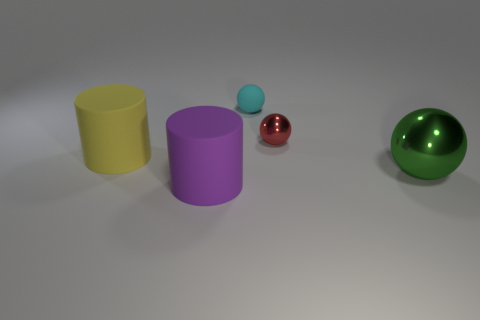There is a metal object that is behind the yellow object; does it have the same shape as the large object that is on the right side of the small matte sphere?
Offer a very short reply. Yes. The tiny shiny object is what color?
Offer a terse response. Red. How many metal things are either big cylinders or tiny red cylinders?
Your response must be concise. 0. There is another large rubber object that is the same shape as the purple rubber thing; what is its color?
Your answer should be compact. Yellow. Is there a big metallic block?
Make the answer very short. No. Do the big cylinder behind the purple matte cylinder and the cylinder right of the yellow rubber cylinder have the same material?
Provide a short and direct response. Yes. How many objects are either large rubber things that are right of the yellow thing or big things behind the big green thing?
Provide a succinct answer. 2. There is a thing behind the red metallic sphere; does it have the same color as the cylinder that is in front of the yellow matte thing?
Your answer should be very brief. No. What is the shape of the object that is both in front of the yellow matte thing and to the left of the small rubber sphere?
Provide a short and direct response. Cylinder. The ball that is the same size as the purple rubber cylinder is what color?
Keep it short and to the point. Green. 